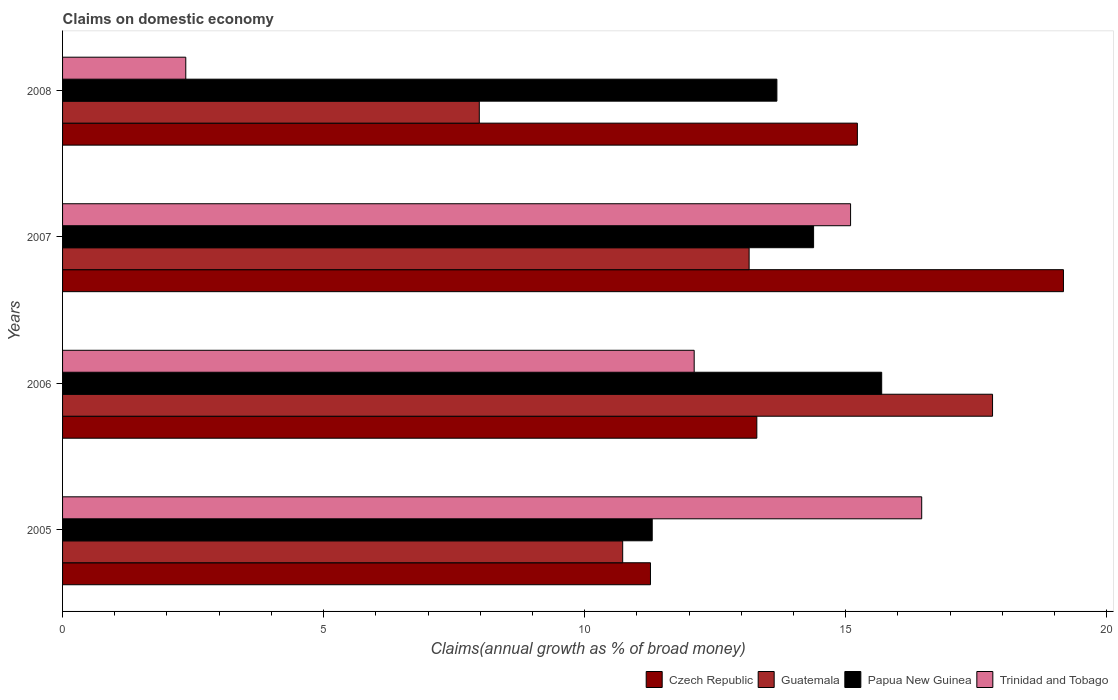How many different coloured bars are there?
Ensure brevity in your answer.  4. Are the number of bars on each tick of the Y-axis equal?
Provide a succinct answer. Yes. How many bars are there on the 1st tick from the bottom?
Provide a short and direct response. 4. What is the percentage of broad money claimed on domestic economy in Trinidad and Tobago in 2006?
Provide a short and direct response. 12.1. Across all years, what is the maximum percentage of broad money claimed on domestic economy in Trinidad and Tobago?
Offer a very short reply. 16.46. Across all years, what is the minimum percentage of broad money claimed on domestic economy in Guatemala?
Offer a terse response. 7.98. In which year was the percentage of broad money claimed on domestic economy in Guatemala maximum?
Make the answer very short. 2006. In which year was the percentage of broad money claimed on domestic economy in Czech Republic minimum?
Your answer should be compact. 2005. What is the total percentage of broad money claimed on domestic economy in Czech Republic in the graph?
Give a very brief answer. 58.96. What is the difference between the percentage of broad money claimed on domestic economy in Papua New Guinea in 2007 and that in 2008?
Provide a short and direct response. 0.7. What is the difference between the percentage of broad money claimed on domestic economy in Trinidad and Tobago in 2006 and the percentage of broad money claimed on domestic economy in Czech Republic in 2005?
Offer a very short reply. 0.84. What is the average percentage of broad money claimed on domestic economy in Trinidad and Tobago per year?
Ensure brevity in your answer.  11.5. In the year 2007, what is the difference between the percentage of broad money claimed on domestic economy in Trinidad and Tobago and percentage of broad money claimed on domestic economy in Papua New Guinea?
Provide a short and direct response. 0.71. In how many years, is the percentage of broad money claimed on domestic economy in Guatemala greater than 16 %?
Give a very brief answer. 1. What is the ratio of the percentage of broad money claimed on domestic economy in Czech Republic in 2007 to that in 2008?
Your answer should be compact. 1.26. Is the difference between the percentage of broad money claimed on domestic economy in Trinidad and Tobago in 2005 and 2007 greater than the difference between the percentage of broad money claimed on domestic economy in Papua New Guinea in 2005 and 2007?
Make the answer very short. Yes. What is the difference between the highest and the second highest percentage of broad money claimed on domestic economy in Trinidad and Tobago?
Give a very brief answer. 1.36. What is the difference between the highest and the lowest percentage of broad money claimed on domestic economy in Czech Republic?
Ensure brevity in your answer.  7.91. In how many years, is the percentage of broad money claimed on domestic economy in Trinidad and Tobago greater than the average percentage of broad money claimed on domestic economy in Trinidad and Tobago taken over all years?
Your response must be concise. 3. Is the sum of the percentage of broad money claimed on domestic economy in Papua New Guinea in 2006 and 2008 greater than the maximum percentage of broad money claimed on domestic economy in Guatemala across all years?
Ensure brevity in your answer.  Yes. What does the 1st bar from the top in 2006 represents?
Offer a very short reply. Trinidad and Tobago. What does the 1st bar from the bottom in 2005 represents?
Your answer should be very brief. Czech Republic. Is it the case that in every year, the sum of the percentage of broad money claimed on domestic economy in Papua New Guinea and percentage of broad money claimed on domestic economy in Trinidad and Tobago is greater than the percentage of broad money claimed on domestic economy in Guatemala?
Ensure brevity in your answer.  Yes. Are all the bars in the graph horizontal?
Make the answer very short. Yes. How many years are there in the graph?
Your response must be concise. 4. Does the graph contain grids?
Provide a succinct answer. No. How are the legend labels stacked?
Offer a terse response. Horizontal. What is the title of the graph?
Provide a succinct answer. Claims on domestic economy. What is the label or title of the X-axis?
Offer a terse response. Claims(annual growth as % of broad money). What is the Claims(annual growth as % of broad money) in Czech Republic in 2005?
Make the answer very short. 11.26. What is the Claims(annual growth as % of broad money) in Guatemala in 2005?
Keep it short and to the point. 10.73. What is the Claims(annual growth as % of broad money) of Papua New Guinea in 2005?
Provide a short and direct response. 11.3. What is the Claims(annual growth as % of broad money) of Trinidad and Tobago in 2005?
Your answer should be compact. 16.46. What is the Claims(annual growth as % of broad money) in Czech Republic in 2006?
Offer a very short reply. 13.3. What is the Claims(annual growth as % of broad money) in Guatemala in 2006?
Give a very brief answer. 17.81. What is the Claims(annual growth as % of broad money) in Papua New Guinea in 2006?
Keep it short and to the point. 15.69. What is the Claims(annual growth as % of broad money) of Trinidad and Tobago in 2006?
Offer a very short reply. 12.1. What is the Claims(annual growth as % of broad money) in Czech Republic in 2007?
Provide a succinct answer. 19.17. What is the Claims(annual growth as % of broad money) in Guatemala in 2007?
Give a very brief answer. 13.15. What is the Claims(annual growth as % of broad money) of Papua New Guinea in 2007?
Your answer should be compact. 14.39. What is the Claims(annual growth as % of broad money) of Trinidad and Tobago in 2007?
Your response must be concise. 15.09. What is the Claims(annual growth as % of broad money) of Czech Republic in 2008?
Your response must be concise. 15.22. What is the Claims(annual growth as % of broad money) of Guatemala in 2008?
Provide a succinct answer. 7.98. What is the Claims(annual growth as % of broad money) of Papua New Guinea in 2008?
Offer a very short reply. 13.68. What is the Claims(annual growth as % of broad money) in Trinidad and Tobago in 2008?
Provide a short and direct response. 2.36. Across all years, what is the maximum Claims(annual growth as % of broad money) in Czech Republic?
Make the answer very short. 19.17. Across all years, what is the maximum Claims(annual growth as % of broad money) in Guatemala?
Keep it short and to the point. 17.81. Across all years, what is the maximum Claims(annual growth as % of broad money) of Papua New Guinea?
Make the answer very short. 15.69. Across all years, what is the maximum Claims(annual growth as % of broad money) in Trinidad and Tobago?
Your answer should be very brief. 16.46. Across all years, what is the minimum Claims(annual growth as % of broad money) of Czech Republic?
Offer a very short reply. 11.26. Across all years, what is the minimum Claims(annual growth as % of broad money) of Guatemala?
Offer a terse response. 7.98. Across all years, what is the minimum Claims(annual growth as % of broad money) of Papua New Guinea?
Keep it short and to the point. 11.3. Across all years, what is the minimum Claims(annual growth as % of broad money) of Trinidad and Tobago?
Make the answer very short. 2.36. What is the total Claims(annual growth as % of broad money) in Czech Republic in the graph?
Provide a short and direct response. 58.96. What is the total Claims(annual growth as % of broad money) in Guatemala in the graph?
Keep it short and to the point. 49.68. What is the total Claims(annual growth as % of broad money) in Papua New Guinea in the graph?
Keep it short and to the point. 55.06. What is the total Claims(annual growth as % of broad money) of Trinidad and Tobago in the graph?
Offer a terse response. 46.01. What is the difference between the Claims(annual growth as % of broad money) in Czech Republic in 2005 and that in 2006?
Offer a terse response. -2.04. What is the difference between the Claims(annual growth as % of broad money) of Guatemala in 2005 and that in 2006?
Keep it short and to the point. -7.08. What is the difference between the Claims(annual growth as % of broad money) of Papua New Guinea in 2005 and that in 2006?
Provide a short and direct response. -4.4. What is the difference between the Claims(annual growth as % of broad money) of Trinidad and Tobago in 2005 and that in 2006?
Ensure brevity in your answer.  4.36. What is the difference between the Claims(annual growth as % of broad money) of Czech Republic in 2005 and that in 2007?
Provide a short and direct response. -7.91. What is the difference between the Claims(annual growth as % of broad money) of Guatemala in 2005 and that in 2007?
Ensure brevity in your answer.  -2.42. What is the difference between the Claims(annual growth as % of broad money) in Papua New Guinea in 2005 and that in 2007?
Your response must be concise. -3.09. What is the difference between the Claims(annual growth as % of broad money) of Trinidad and Tobago in 2005 and that in 2007?
Offer a terse response. 1.36. What is the difference between the Claims(annual growth as % of broad money) in Czech Republic in 2005 and that in 2008?
Your answer should be compact. -3.96. What is the difference between the Claims(annual growth as % of broad money) in Guatemala in 2005 and that in 2008?
Your answer should be compact. 2.75. What is the difference between the Claims(annual growth as % of broad money) in Papua New Guinea in 2005 and that in 2008?
Provide a short and direct response. -2.39. What is the difference between the Claims(annual growth as % of broad money) of Trinidad and Tobago in 2005 and that in 2008?
Offer a terse response. 14.1. What is the difference between the Claims(annual growth as % of broad money) of Czech Republic in 2006 and that in 2007?
Your response must be concise. -5.87. What is the difference between the Claims(annual growth as % of broad money) of Guatemala in 2006 and that in 2007?
Offer a terse response. 4.66. What is the difference between the Claims(annual growth as % of broad money) in Papua New Guinea in 2006 and that in 2007?
Ensure brevity in your answer.  1.3. What is the difference between the Claims(annual growth as % of broad money) of Trinidad and Tobago in 2006 and that in 2007?
Provide a succinct answer. -3. What is the difference between the Claims(annual growth as % of broad money) of Czech Republic in 2006 and that in 2008?
Your answer should be very brief. -1.93. What is the difference between the Claims(annual growth as % of broad money) in Guatemala in 2006 and that in 2008?
Ensure brevity in your answer.  9.83. What is the difference between the Claims(annual growth as % of broad money) of Papua New Guinea in 2006 and that in 2008?
Provide a succinct answer. 2.01. What is the difference between the Claims(annual growth as % of broad money) of Trinidad and Tobago in 2006 and that in 2008?
Ensure brevity in your answer.  9.74. What is the difference between the Claims(annual growth as % of broad money) in Czech Republic in 2007 and that in 2008?
Give a very brief answer. 3.95. What is the difference between the Claims(annual growth as % of broad money) of Guatemala in 2007 and that in 2008?
Your answer should be very brief. 5.17. What is the difference between the Claims(annual growth as % of broad money) of Papua New Guinea in 2007 and that in 2008?
Provide a short and direct response. 0.7. What is the difference between the Claims(annual growth as % of broad money) of Trinidad and Tobago in 2007 and that in 2008?
Give a very brief answer. 12.73. What is the difference between the Claims(annual growth as % of broad money) of Czech Republic in 2005 and the Claims(annual growth as % of broad money) of Guatemala in 2006?
Keep it short and to the point. -6.55. What is the difference between the Claims(annual growth as % of broad money) of Czech Republic in 2005 and the Claims(annual growth as % of broad money) of Papua New Guinea in 2006?
Give a very brief answer. -4.43. What is the difference between the Claims(annual growth as % of broad money) of Czech Republic in 2005 and the Claims(annual growth as % of broad money) of Trinidad and Tobago in 2006?
Your response must be concise. -0.84. What is the difference between the Claims(annual growth as % of broad money) in Guatemala in 2005 and the Claims(annual growth as % of broad money) in Papua New Guinea in 2006?
Your response must be concise. -4.96. What is the difference between the Claims(annual growth as % of broad money) in Guatemala in 2005 and the Claims(annual growth as % of broad money) in Trinidad and Tobago in 2006?
Your answer should be very brief. -1.37. What is the difference between the Claims(annual growth as % of broad money) in Papua New Guinea in 2005 and the Claims(annual growth as % of broad money) in Trinidad and Tobago in 2006?
Your answer should be very brief. -0.8. What is the difference between the Claims(annual growth as % of broad money) of Czech Republic in 2005 and the Claims(annual growth as % of broad money) of Guatemala in 2007?
Provide a succinct answer. -1.89. What is the difference between the Claims(annual growth as % of broad money) in Czech Republic in 2005 and the Claims(annual growth as % of broad money) in Papua New Guinea in 2007?
Offer a very short reply. -3.12. What is the difference between the Claims(annual growth as % of broad money) in Czech Republic in 2005 and the Claims(annual growth as % of broad money) in Trinidad and Tobago in 2007?
Provide a short and direct response. -3.83. What is the difference between the Claims(annual growth as % of broad money) of Guatemala in 2005 and the Claims(annual growth as % of broad money) of Papua New Guinea in 2007?
Make the answer very short. -3.66. What is the difference between the Claims(annual growth as % of broad money) of Guatemala in 2005 and the Claims(annual growth as % of broad money) of Trinidad and Tobago in 2007?
Make the answer very short. -4.37. What is the difference between the Claims(annual growth as % of broad money) of Papua New Guinea in 2005 and the Claims(annual growth as % of broad money) of Trinidad and Tobago in 2007?
Your answer should be compact. -3.8. What is the difference between the Claims(annual growth as % of broad money) of Czech Republic in 2005 and the Claims(annual growth as % of broad money) of Guatemala in 2008?
Your response must be concise. 3.28. What is the difference between the Claims(annual growth as % of broad money) of Czech Republic in 2005 and the Claims(annual growth as % of broad money) of Papua New Guinea in 2008?
Provide a short and direct response. -2.42. What is the difference between the Claims(annual growth as % of broad money) in Czech Republic in 2005 and the Claims(annual growth as % of broad money) in Trinidad and Tobago in 2008?
Give a very brief answer. 8.9. What is the difference between the Claims(annual growth as % of broad money) in Guatemala in 2005 and the Claims(annual growth as % of broad money) in Papua New Guinea in 2008?
Provide a short and direct response. -2.95. What is the difference between the Claims(annual growth as % of broad money) of Guatemala in 2005 and the Claims(annual growth as % of broad money) of Trinidad and Tobago in 2008?
Your response must be concise. 8.37. What is the difference between the Claims(annual growth as % of broad money) in Papua New Guinea in 2005 and the Claims(annual growth as % of broad money) in Trinidad and Tobago in 2008?
Give a very brief answer. 8.94. What is the difference between the Claims(annual growth as % of broad money) in Czech Republic in 2006 and the Claims(annual growth as % of broad money) in Guatemala in 2007?
Provide a short and direct response. 0.15. What is the difference between the Claims(annual growth as % of broad money) in Czech Republic in 2006 and the Claims(annual growth as % of broad money) in Papua New Guinea in 2007?
Make the answer very short. -1.09. What is the difference between the Claims(annual growth as % of broad money) of Czech Republic in 2006 and the Claims(annual growth as % of broad money) of Trinidad and Tobago in 2007?
Ensure brevity in your answer.  -1.8. What is the difference between the Claims(annual growth as % of broad money) in Guatemala in 2006 and the Claims(annual growth as % of broad money) in Papua New Guinea in 2007?
Give a very brief answer. 3.43. What is the difference between the Claims(annual growth as % of broad money) of Guatemala in 2006 and the Claims(annual growth as % of broad money) of Trinidad and Tobago in 2007?
Provide a short and direct response. 2.72. What is the difference between the Claims(annual growth as % of broad money) of Papua New Guinea in 2006 and the Claims(annual growth as % of broad money) of Trinidad and Tobago in 2007?
Your response must be concise. 0.6. What is the difference between the Claims(annual growth as % of broad money) in Czech Republic in 2006 and the Claims(annual growth as % of broad money) in Guatemala in 2008?
Your response must be concise. 5.32. What is the difference between the Claims(annual growth as % of broad money) in Czech Republic in 2006 and the Claims(annual growth as % of broad money) in Papua New Guinea in 2008?
Your response must be concise. -0.38. What is the difference between the Claims(annual growth as % of broad money) of Czech Republic in 2006 and the Claims(annual growth as % of broad money) of Trinidad and Tobago in 2008?
Your answer should be compact. 10.94. What is the difference between the Claims(annual growth as % of broad money) of Guatemala in 2006 and the Claims(annual growth as % of broad money) of Papua New Guinea in 2008?
Your answer should be compact. 4.13. What is the difference between the Claims(annual growth as % of broad money) in Guatemala in 2006 and the Claims(annual growth as % of broad money) in Trinidad and Tobago in 2008?
Provide a short and direct response. 15.45. What is the difference between the Claims(annual growth as % of broad money) in Papua New Guinea in 2006 and the Claims(annual growth as % of broad money) in Trinidad and Tobago in 2008?
Provide a short and direct response. 13.33. What is the difference between the Claims(annual growth as % of broad money) in Czech Republic in 2007 and the Claims(annual growth as % of broad money) in Guatemala in 2008?
Provide a succinct answer. 11.19. What is the difference between the Claims(annual growth as % of broad money) in Czech Republic in 2007 and the Claims(annual growth as % of broad money) in Papua New Guinea in 2008?
Keep it short and to the point. 5.49. What is the difference between the Claims(annual growth as % of broad money) in Czech Republic in 2007 and the Claims(annual growth as % of broad money) in Trinidad and Tobago in 2008?
Give a very brief answer. 16.81. What is the difference between the Claims(annual growth as % of broad money) of Guatemala in 2007 and the Claims(annual growth as % of broad money) of Papua New Guinea in 2008?
Provide a short and direct response. -0.53. What is the difference between the Claims(annual growth as % of broad money) of Guatemala in 2007 and the Claims(annual growth as % of broad money) of Trinidad and Tobago in 2008?
Your response must be concise. 10.79. What is the difference between the Claims(annual growth as % of broad money) of Papua New Guinea in 2007 and the Claims(annual growth as % of broad money) of Trinidad and Tobago in 2008?
Provide a short and direct response. 12.03. What is the average Claims(annual growth as % of broad money) in Czech Republic per year?
Make the answer very short. 14.74. What is the average Claims(annual growth as % of broad money) of Guatemala per year?
Your answer should be very brief. 12.42. What is the average Claims(annual growth as % of broad money) in Papua New Guinea per year?
Provide a succinct answer. 13.76. What is the average Claims(annual growth as % of broad money) in Trinidad and Tobago per year?
Give a very brief answer. 11.5. In the year 2005, what is the difference between the Claims(annual growth as % of broad money) in Czech Republic and Claims(annual growth as % of broad money) in Guatemala?
Your answer should be very brief. 0.53. In the year 2005, what is the difference between the Claims(annual growth as % of broad money) of Czech Republic and Claims(annual growth as % of broad money) of Papua New Guinea?
Keep it short and to the point. -0.03. In the year 2005, what is the difference between the Claims(annual growth as % of broad money) in Czech Republic and Claims(annual growth as % of broad money) in Trinidad and Tobago?
Give a very brief answer. -5.2. In the year 2005, what is the difference between the Claims(annual growth as % of broad money) of Guatemala and Claims(annual growth as % of broad money) of Papua New Guinea?
Offer a very short reply. -0.57. In the year 2005, what is the difference between the Claims(annual growth as % of broad money) in Guatemala and Claims(annual growth as % of broad money) in Trinidad and Tobago?
Offer a very short reply. -5.73. In the year 2005, what is the difference between the Claims(annual growth as % of broad money) in Papua New Guinea and Claims(annual growth as % of broad money) in Trinidad and Tobago?
Provide a short and direct response. -5.16. In the year 2006, what is the difference between the Claims(annual growth as % of broad money) in Czech Republic and Claims(annual growth as % of broad money) in Guatemala?
Make the answer very short. -4.52. In the year 2006, what is the difference between the Claims(annual growth as % of broad money) of Czech Republic and Claims(annual growth as % of broad money) of Papua New Guinea?
Make the answer very short. -2.39. In the year 2006, what is the difference between the Claims(annual growth as % of broad money) of Czech Republic and Claims(annual growth as % of broad money) of Trinidad and Tobago?
Make the answer very short. 1.2. In the year 2006, what is the difference between the Claims(annual growth as % of broad money) in Guatemala and Claims(annual growth as % of broad money) in Papua New Guinea?
Ensure brevity in your answer.  2.12. In the year 2006, what is the difference between the Claims(annual growth as % of broad money) in Guatemala and Claims(annual growth as % of broad money) in Trinidad and Tobago?
Provide a succinct answer. 5.72. In the year 2006, what is the difference between the Claims(annual growth as % of broad money) in Papua New Guinea and Claims(annual growth as % of broad money) in Trinidad and Tobago?
Give a very brief answer. 3.59. In the year 2007, what is the difference between the Claims(annual growth as % of broad money) in Czech Republic and Claims(annual growth as % of broad money) in Guatemala?
Provide a short and direct response. 6.02. In the year 2007, what is the difference between the Claims(annual growth as % of broad money) of Czech Republic and Claims(annual growth as % of broad money) of Papua New Guinea?
Your answer should be very brief. 4.79. In the year 2007, what is the difference between the Claims(annual growth as % of broad money) of Czech Republic and Claims(annual growth as % of broad money) of Trinidad and Tobago?
Make the answer very short. 4.08. In the year 2007, what is the difference between the Claims(annual growth as % of broad money) in Guatemala and Claims(annual growth as % of broad money) in Papua New Guinea?
Provide a short and direct response. -1.23. In the year 2007, what is the difference between the Claims(annual growth as % of broad money) in Guatemala and Claims(annual growth as % of broad money) in Trinidad and Tobago?
Your answer should be very brief. -1.94. In the year 2007, what is the difference between the Claims(annual growth as % of broad money) of Papua New Guinea and Claims(annual growth as % of broad money) of Trinidad and Tobago?
Provide a succinct answer. -0.71. In the year 2008, what is the difference between the Claims(annual growth as % of broad money) of Czech Republic and Claims(annual growth as % of broad money) of Guatemala?
Make the answer very short. 7.24. In the year 2008, what is the difference between the Claims(annual growth as % of broad money) in Czech Republic and Claims(annual growth as % of broad money) in Papua New Guinea?
Offer a terse response. 1.54. In the year 2008, what is the difference between the Claims(annual growth as % of broad money) in Czech Republic and Claims(annual growth as % of broad money) in Trinidad and Tobago?
Provide a succinct answer. 12.86. In the year 2008, what is the difference between the Claims(annual growth as % of broad money) in Guatemala and Claims(annual growth as % of broad money) in Papua New Guinea?
Provide a short and direct response. -5.7. In the year 2008, what is the difference between the Claims(annual growth as % of broad money) of Guatemala and Claims(annual growth as % of broad money) of Trinidad and Tobago?
Make the answer very short. 5.62. In the year 2008, what is the difference between the Claims(annual growth as % of broad money) of Papua New Guinea and Claims(annual growth as % of broad money) of Trinidad and Tobago?
Make the answer very short. 11.32. What is the ratio of the Claims(annual growth as % of broad money) in Czech Republic in 2005 to that in 2006?
Your response must be concise. 0.85. What is the ratio of the Claims(annual growth as % of broad money) in Guatemala in 2005 to that in 2006?
Ensure brevity in your answer.  0.6. What is the ratio of the Claims(annual growth as % of broad money) of Papua New Guinea in 2005 to that in 2006?
Keep it short and to the point. 0.72. What is the ratio of the Claims(annual growth as % of broad money) of Trinidad and Tobago in 2005 to that in 2006?
Offer a terse response. 1.36. What is the ratio of the Claims(annual growth as % of broad money) of Czech Republic in 2005 to that in 2007?
Your answer should be very brief. 0.59. What is the ratio of the Claims(annual growth as % of broad money) in Guatemala in 2005 to that in 2007?
Your response must be concise. 0.82. What is the ratio of the Claims(annual growth as % of broad money) of Papua New Guinea in 2005 to that in 2007?
Your answer should be very brief. 0.79. What is the ratio of the Claims(annual growth as % of broad money) of Trinidad and Tobago in 2005 to that in 2007?
Give a very brief answer. 1.09. What is the ratio of the Claims(annual growth as % of broad money) in Czech Republic in 2005 to that in 2008?
Keep it short and to the point. 0.74. What is the ratio of the Claims(annual growth as % of broad money) in Guatemala in 2005 to that in 2008?
Give a very brief answer. 1.34. What is the ratio of the Claims(annual growth as % of broad money) of Papua New Guinea in 2005 to that in 2008?
Make the answer very short. 0.83. What is the ratio of the Claims(annual growth as % of broad money) in Trinidad and Tobago in 2005 to that in 2008?
Your response must be concise. 6.97. What is the ratio of the Claims(annual growth as % of broad money) in Czech Republic in 2006 to that in 2007?
Provide a succinct answer. 0.69. What is the ratio of the Claims(annual growth as % of broad money) of Guatemala in 2006 to that in 2007?
Provide a succinct answer. 1.35. What is the ratio of the Claims(annual growth as % of broad money) in Papua New Guinea in 2006 to that in 2007?
Your answer should be compact. 1.09. What is the ratio of the Claims(annual growth as % of broad money) of Trinidad and Tobago in 2006 to that in 2007?
Offer a very short reply. 0.8. What is the ratio of the Claims(annual growth as % of broad money) of Czech Republic in 2006 to that in 2008?
Give a very brief answer. 0.87. What is the ratio of the Claims(annual growth as % of broad money) in Guatemala in 2006 to that in 2008?
Keep it short and to the point. 2.23. What is the ratio of the Claims(annual growth as % of broad money) of Papua New Guinea in 2006 to that in 2008?
Offer a terse response. 1.15. What is the ratio of the Claims(annual growth as % of broad money) in Trinidad and Tobago in 2006 to that in 2008?
Keep it short and to the point. 5.13. What is the ratio of the Claims(annual growth as % of broad money) in Czech Republic in 2007 to that in 2008?
Provide a succinct answer. 1.26. What is the ratio of the Claims(annual growth as % of broad money) in Guatemala in 2007 to that in 2008?
Your response must be concise. 1.65. What is the ratio of the Claims(annual growth as % of broad money) of Papua New Guinea in 2007 to that in 2008?
Keep it short and to the point. 1.05. What is the ratio of the Claims(annual growth as % of broad money) of Trinidad and Tobago in 2007 to that in 2008?
Make the answer very short. 6.4. What is the difference between the highest and the second highest Claims(annual growth as % of broad money) in Czech Republic?
Your answer should be compact. 3.95. What is the difference between the highest and the second highest Claims(annual growth as % of broad money) in Guatemala?
Make the answer very short. 4.66. What is the difference between the highest and the second highest Claims(annual growth as % of broad money) in Papua New Guinea?
Keep it short and to the point. 1.3. What is the difference between the highest and the second highest Claims(annual growth as % of broad money) of Trinidad and Tobago?
Give a very brief answer. 1.36. What is the difference between the highest and the lowest Claims(annual growth as % of broad money) of Czech Republic?
Offer a terse response. 7.91. What is the difference between the highest and the lowest Claims(annual growth as % of broad money) of Guatemala?
Your response must be concise. 9.83. What is the difference between the highest and the lowest Claims(annual growth as % of broad money) of Papua New Guinea?
Give a very brief answer. 4.4. What is the difference between the highest and the lowest Claims(annual growth as % of broad money) in Trinidad and Tobago?
Provide a short and direct response. 14.1. 